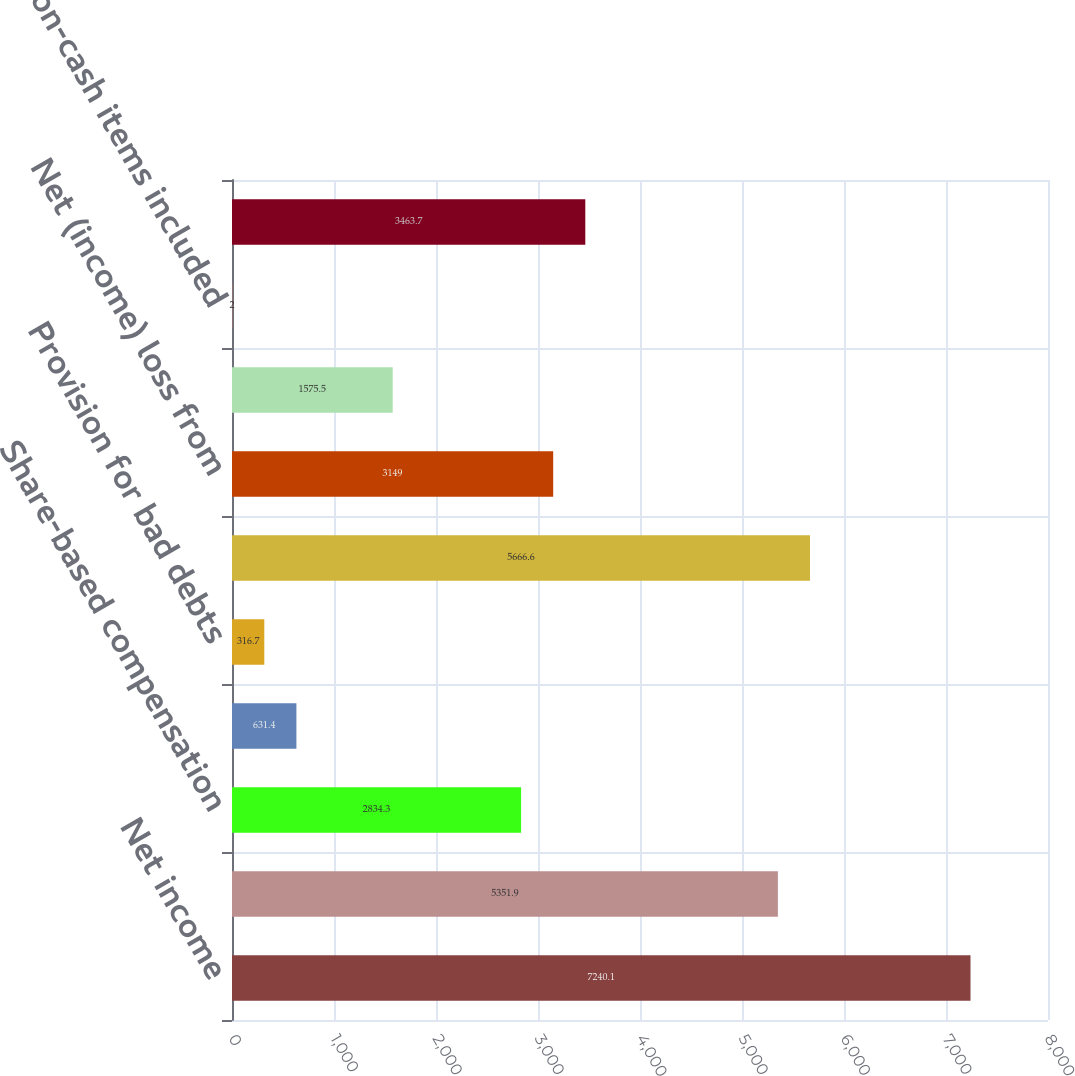<chart> <loc_0><loc_0><loc_500><loc_500><bar_chart><fcel>Net income<fcel>Depreciation and amortization<fcel>Share-based compensation<fcel>Excess tax benefits related to<fcel>Provision for bad debts<fcel>Deferred taxes net<fcel>Net (income) loss from<fcel>Accretion of 250 convertible<fcel>Other non-cash items included<fcel>Receivables net<nl><fcel>7240.1<fcel>5351.9<fcel>2834.3<fcel>631.4<fcel>316.7<fcel>5666.6<fcel>3149<fcel>1575.5<fcel>2<fcel>3463.7<nl></chart> 